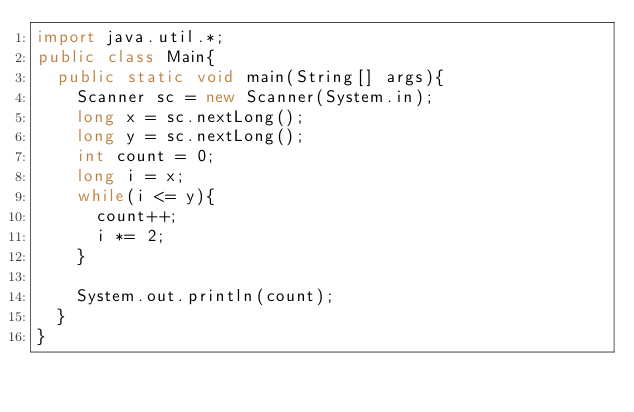Convert code to text. <code><loc_0><loc_0><loc_500><loc_500><_Java_>import java.util.*;
public class Main{
  public static void main(String[] args){
    Scanner sc = new Scanner(System.in);
    long x = sc.nextLong();
    long y = sc.nextLong();
    int count = 0;
    long i = x;
    while(i <= y){
      count++;
      i *= 2;
    }
    
    System.out.println(count);
  }
}</code> 